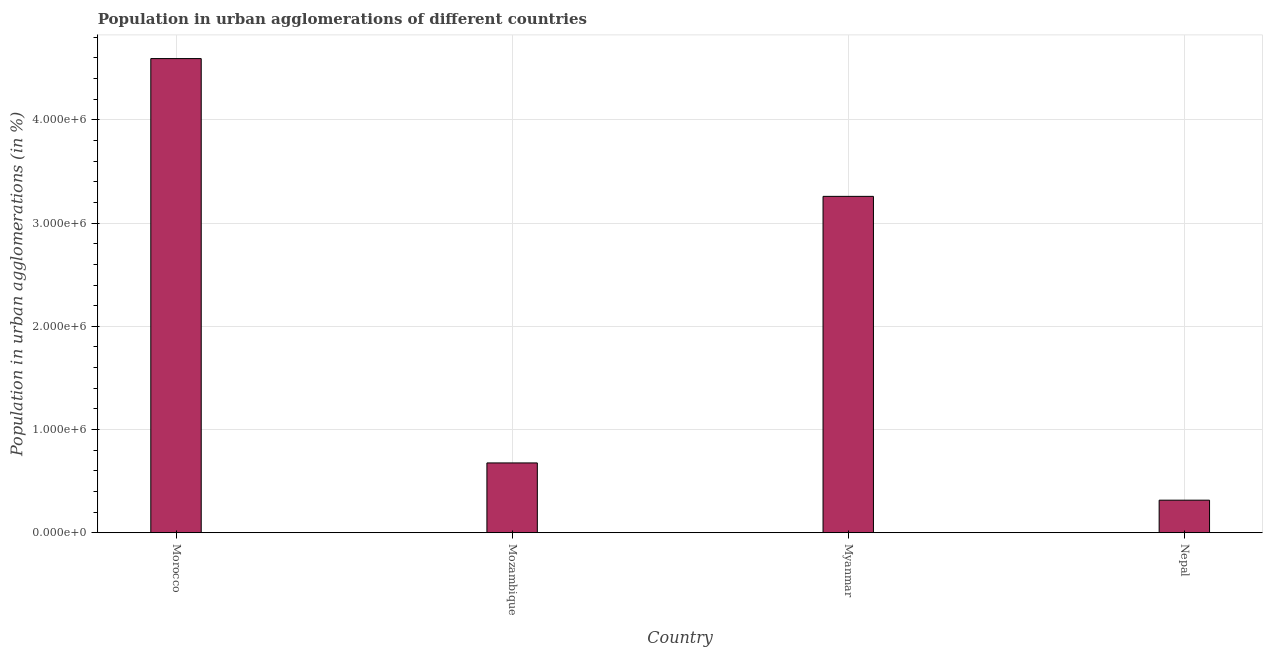Does the graph contain any zero values?
Ensure brevity in your answer.  No. What is the title of the graph?
Give a very brief answer. Population in urban agglomerations of different countries. What is the label or title of the Y-axis?
Provide a succinct answer. Population in urban agglomerations (in %). What is the population in urban agglomerations in Myanmar?
Offer a very short reply. 3.26e+06. Across all countries, what is the maximum population in urban agglomerations?
Make the answer very short. 4.59e+06. Across all countries, what is the minimum population in urban agglomerations?
Offer a terse response. 3.15e+05. In which country was the population in urban agglomerations maximum?
Offer a terse response. Morocco. In which country was the population in urban agglomerations minimum?
Your answer should be compact. Nepal. What is the sum of the population in urban agglomerations?
Offer a very short reply. 8.85e+06. What is the difference between the population in urban agglomerations in Morocco and Mozambique?
Make the answer very short. 3.92e+06. What is the average population in urban agglomerations per country?
Keep it short and to the point. 2.21e+06. What is the median population in urban agglomerations?
Give a very brief answer. 1.97e+06. What is the ratio of the population in urban agglomerations in Morocco to that in Myanmar?
Provide a short and direct response. 1.41. Is the population in urban agglomerations in Morocco less than that in Nepal?
Provide a succinct answer. No. Is the difference between the population in urban agglomerations in Mozambique and Nepal greater than the difference between any two countries?
Give a very brief answer. No. What is the difference between the highest and the second highest population in urban agglomerations?
Provide a succinct answer. 1.34e+06. What is the difference between the highest and the lowest population in urban agglomerations?
Give a very brief answer. 4.28e+06. In how many countries, is the population in urban agglomerations greater than the average population in urban agglomerations taken over all countries?
Ensure brevity in your answer.  2. How many bars are there?
Offer a terse response. 4. Are all the bars in the graph horizontal?
Your answer should be compact. No. How many countries are there in the graph?
Give a very brief answer. 4. What is the Population in urban agglomerations (in %) in Morocco?
Give a very brief answer. 4.59e+06. What is the Population in urban agglomerations (in %) of Mozambique?
Ensure brevity in your answer.  6.76e+05. What is the Population in urban agglomerations (in %) in Myanmar?
Make the answer very short. 3.26e+06. What is the Population in urban agglomerations (in %) in Nepal?
Your response must be concise. 3.15e+05. What is the difference between the Population in urban agglomerations (in %) in Morocco and Mozambique?
Your answer should be compact. 3.92e+06. What is the difference between the Population in urban agglomerations (in %) in Morocco and Myanmar?
Keep it short and to the point. 1.34e+06. What is the difference between the Population in urban agglomerations (in %) in Morocco and Nepal?
Your response must be concise. 4.28e+06. What is the difference between the Population in urban agglomerations (in %) in Mozambique and Myanmar?
Offer a terse response. -2.58e+06. What is the difference between the Population in urban agglomerations (in %) in Mozambique and Nepal?
Your response must be concise. 3.61e+05. What is the difference between the Population in urban agglomerations (in %) in Myanmar and Nepal?
Offer a terse response. 2.94e+06. What is the ratio of the Population in urban agglomerations (in %) in Morocco to that in Mozambique?
Make the answer very short. 6.79. What is the ratio of the Population in urban agglomerations (in %) in Morocco to that in Myanmar?
Give a very brief answer. 1.41. What is the ratio of the Population in urban agglomerations (in %) in Morocco to that in Nepal?
Ensure brevity in your answer.  14.58. What is the ratio of the Population in urban agglomerations (in %) in Mozambique to that in Myanmar?
Offer a terse response. 0.21. What is the ratio of the Population in urban agglomerations (in %) in Mozambique to that in Nepal?
Your response must be concise. 2.15. What is the ratio of the Population in urban agglomerations (in %) in Myanmar to that in Nepal?
Offer a very short reply. 10.34. 